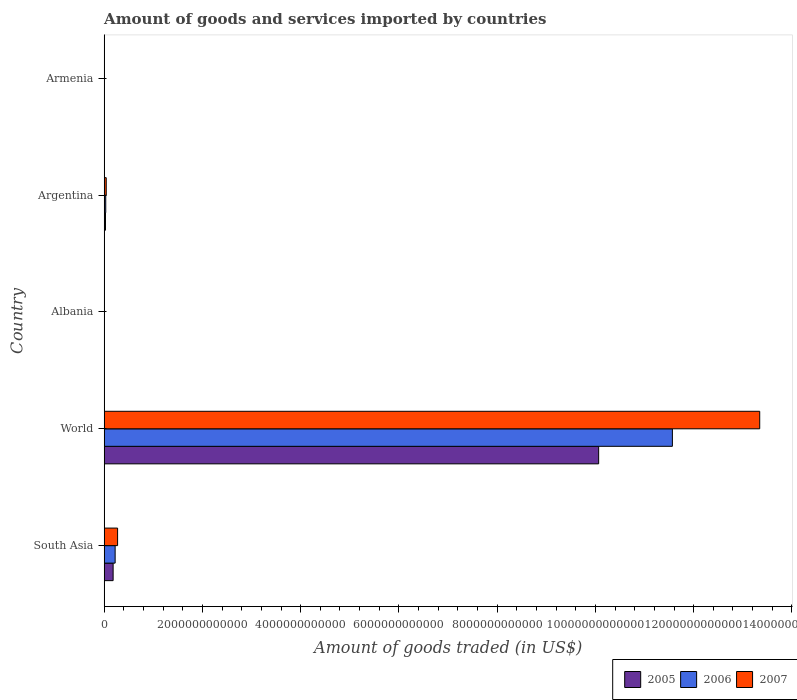Are the number of bars per tick equal to the number of legend labels?
Your answer should be very brief. Yes. What is the label of the 1st group of bars from the top?
Your answer should be compact. Armenia. In how many cases, is the number of bars for a given country not equal to the number of legend labels?
Give a very brief answer. 0. What is the total amount of goods and services imported in 2007 in Armenia?
Offer a terse response. 2.92e+09. Across all countries, what is the maximum total amount of goods and services imported in 2005?
Offer a very short reply. 1.01e+13. Across all countries, what is the minimum total amount of goods and services imported in 2006?
Provide a succinct answer. 2.00e+09. In which country was the total amount of goods and services imported in 2005 minimum?
Provide a succinct answer. Armenia. What is the total total amount of goods and services imported in 2006 in the graph?
Offer a very short reply. 1.18e+13. What is the difference between the total amount of goods and services imported in 2005 in Argentina and that in World?
Make the answer very short. -1.00e+13. What is the difference between the total amount of goods and services imported in 2006 in Albania and the total amount of goods and services imported in 2005 in World?
Provide a succinct answer. -1.01e+13. What is the average total amount of goods and services imported in 2006 per country?
Provide a short and direct response. 2.37e+12. What is the difference between the total amount of goods and services imported in 2005 and total amount of goods and services imported in 2006 in World?
Offer a very short reply. -1.50e+12. What is the ratio of the total amount of goods and services imported in 2006 in Albania to that in South Asia?
Ensure brevity in your answer.  0.01. Is the total amount of goods and services imported in 2005 in Armenia less than that in South Asia?
Provide a short and direct response. Yes. What is the difference between the highest and the second highest total amount of goods and services imported in 2007?
Offer a very short reply. 1.31e+13. What is the difference between the highest and the lowest total amount of goods and services imported in 2005?
Give a very brief answer. 1.01e+13. Is the sum of the total amount of goods and services imported in 2007 in Albania and Armenia greater than the maximum total amount of goods and services imported in 2006 across all countries?
Provide a succinct answer. No. Is it the case that in every country, the sum of the total amount of goods and services imported in 2005 and total amount of goods and services imported in 2006 is greater than the total amount of goods and services imported in 2007?
Make the answer very short. Yes. How many bars are there?
Keep it short and to the point. 15. Are all the bars in the graph horizontal?
Ensure brevity in your answer.  Yes. How many countries are there in the graph?
Your answer should be very brief. 5. What is the difference between two consecutive major ticks on the X-axis?
Keep it short and to the point. 2.00e+12. Are the values on the major ticks of X-axis written in scientific E-notation?
Provide a succinct answer. No. How many legend labels are there?
Keep it short and to the point. 3. How are the legend labels stacked?
Give a very brief answer. Horizontal. What is the title of the graph?
Ensure brevity in your answer.  Amount of goods and services imported by countries. What is the label or title of the X-axis?
Make the answer very short. Amount of goods traded (in US$). What is the Amount of goods traded (in US$) of 2005 in South Asia?
Provide a succinct answer. 1.83e+11. What is the Amount of goods traded (in US$) in 2006 in South Asia?
Your answer should be very brief. 2.24e+11. What is the Amount of goods traded (in US$) in 2007 in South Asia?
Provide a succinct answer. 2.74e+11. What is the Amount of goods traded (in US$) of 2005 in World?
Keep it short and to the point. 1.01e+13. What is the Amount of goods traded (in US$) of 2006 in World?
Make the answer very short. 1.16e+13. What is the Amount of goods traded (in US$) of 2007 in World?
Offer a terse response. 1.33e+13. What is the Amount of goods traded (in US$) of 2005 in Albania?
Keep it short and to the point. 2.12e+09. What is the Amount of goods traded (in US$) of 2006 in Albania?
Make the answer very short. 2.50e+09. What is the Amount of goods traded (in US$) in 2007 in Albania?
Offer a terse response. 3.42e+09. What is the Amount of goods traded (in US$) of 2005 in Argentina?
Ensure brevity in your answer.  2.73e+1. What is the Amount of goods traded (in US$) of 2006 in Argentina?
Your answer should be compact. 3.26e+1. What is the Amount of goods traded (in US$) in 2007 in Argentina?
Your answer should be very brief. 4.25e+1. What is the Amount of goods traded (in US$) of 2005 in Armenia?
Offer a terse response. 1.66e+09. What is the Amount of goods traded (in US$) of 2006 in Armenia?
Your answer should be compact. 2.00e+09. What is the Amount of goods traded (in US$) of 2007 in Armenia?
Offer a very short reply. 2.92e+09. Across all countries, what is the maximum Amount of goods traded (in US$) in 2005?
Your response must be concise. 1.01e+13. Across all countries, what is the maximum Amount of goods traded (in US$) in 2006?
Provide a succinct answer. 1.16e+13. Across all countries, what is the maximum Amount of goods traded (in US$) in 2007?
Offer a very short reply. 1.33e+13. Across all countries, what is the minimum Amount of goods traded (in US$) of 2005?
Your answer should be very brief. 1.66e+09. Across all countries, what is the minimum Amount of goods traded (in US$) of 2006?
Offer a terse response. 2.00e+09. Across all countries, what is the minimum Amount of goods traded (in US$) in 2007?
Your response must be concise. 2.92e+09. What is the total Amount of goods traded (in US$) of 2005 in the graph?
Make the answer very short. 1.03e+13. What is the total Amount of goods traded (in US$) of 2006 in the graph?
Offer a terse response. 1.18e+13. What is the total Amount of goods traded (in US$) of 2007 in the graph?
Your response must be concise. 1.37e+13. What is the difference between the Amount of goods traded (in US$) in 2005 in South Asia and that in World?
Your response must be concise. -9.88e+12. What is the difference between the Amount of goods traded (in US$) of 2006 in South Asia and that in World?
Your answer should be compact. -1.13e+13. What is the difference between the Amount of goods traded (in US$) of 2007 in South Asia and that in World?
Your response must be concise. -1.31e+13. What is the difference between the Amount of goods traded (in US$) in 2005 in South Asia and that in Albania?
Provide a succinct answer. 1.81e+11. What is the difference between the Amount of goods traded (in US$) in 2006 in South Asia and that in Albania?
Keep it short and to the point. 2.21e+11. What is the difference between the Amount of goods traded (in US$) of 2007 in South Asia and that in Albania?
Provide a short and direct response. 2.70e+11. What is the difference between the Amount of goods traded (in US$) in 2005 in South Asia and that in Argentina?
Give a very brief answer. 1.55e+11. What is the difference between the Amount of goods traded (in US$) of 2006 in South Asia and that in Argentina?
Your answer should be very brief. 1.91e+11. What is the difference between the Amount of goods traded (in US$) of 2007 in South Asia and that in Argentina?
Give a very brief answer. 2.31e+11. What is the difference between the Amount of goods traded (in US$) of 2005 in South Asia and that in Armenia?
Provide a short and direct response. 1.81e+11. What is the difference between the Amount of goods traded (in US$) of 2006 in South Asia and that in Armenia?
Provide a short and direct response. 2.22e+11. What is the difference between the Amount of goods traded (in US$) of 2007 in South Asia and that in Armenia?
Offer a very short reply. 2.71e+11. What is the difference between the Amount of goods traded (in US$) in 2005 in World and that in Albania?
Make the answer very short. 1.01e+13. What is the difference between the Amount of goods traded (in US$) of 2006 in World and that in Albania?
Offer a very short reply. 1.16e+13. What is the difference between the Amount of goods traded (in US$) of 2007 in World and that in Albania?
Provide a short and direct response. 1.33e+13. What is the difference between the Amount of goods traded (in US$) of 2005 in World and that in Argentina?
Keep it short and to the point. 1.00e+13. What is the difference between the Amount of goods traded (in US$) of 2006 in World and that in Argentina?
Give a very brief answer. 1.15e+13. What is the difference between the Amount of goods traded (in US$) in 2007 in World and that in Argentina?
Ensure brevity in your answer.  1.33e+13. What is the difference between the Amount of goods traded (in US$) of 2005 in World and that in Armenia?
Give a very brief answer. 1.01e+13. What is the difference between the Amount of goods traded (in US$) in 2006 in World and that in Armenia?
Your answer should be compact. 1.16e+13. What is the difference between the Amount of goods traded (in US$) of 2007 in World and that in Armenia?
Keep it short and to the point. 1.33e+13. What is the difference between the Amount of goods traded (in US$) of 2005 in Albania and that in Argentina?
Provide a succinct answer. -2.52e+1. What is the difference between the Amount of goods traded (in US$) of 2006 in Albania and that in Argentina?
Your response must be concise. -3.01e+1. What is the difference between the Amount of goods traded (in US$) in 2007 in Albania and that in Argentina?
Ensure brevity in your answer.  -3.91e+1. What is the difference between the Amount of goods traded (in US$) of 2005 in Albania and that in Armenia?
Offer a terse response. 4.54e+08. What is the difference between the Amount of goods traded (in US$) of 2006 in Albania and that in Armenia?
Your response must be concise. 5.00e+08. What is the difference between the Amount of goods traded (in US$) of 2007 in Albania and that in Armenia?
Offer a terse response. 4.99e+08. What is the difference between the Amount of goods traded (in US$) of 2005 in Argentina and that in Armenia?
Your response must be concise. 2.56e+1. What is the difference between the Amount of goods traded (in US$) in 2006 in Argentina and that in Armenia?
Ensure brevity in your answer.  3.06e+1. What is the difference between the Amount of goods traded (in US$) in 2007 in Argentina and that in Armenia?
Provide a succinct answer. 3.96e+1. What is the difference between the Amount of goods traded (in US$) in 2005 in South Asia and the Amount of goods traded (in US$) in 2006 in World?
Provide a succinct answer. -1.14e+13. What is the difference between the Amount of goods traded (in US$) in 2005 in South Asia and the Amount of goods traded (in US$) in 2007 in World?
Provide a short and direct response. -1.32e+13. What is the difference between the Amount of goods traded (in US$) in 2006 in South Asia and the Amount of goods traded (in US$) in 2007 in World?
Keep it short and to the point. -1.31e+13. What is the difference between the Amount of goods traded (in US$) of 2005 in South Asia and the Amount of goods traded (in US$) of 2006 in Albania?
Make the answer very short. 1.80e+11. What is the difference between the Amount of goods traded (in US$) in 2005 in South Asia and the Amount of goods traded (in US$) in 2007 in Albania?
Ensure brevity in your answer.  1.79e+11. What is the difference between the Amount of goods traded (in US$) of 2006 in South Asia and the Amount of goods traded (in US$) of 2007 in Albania?
Offer a terse response. 2.20e+11. What is the difference between the Amount of goods traded (in US$) of 2005 in South Asia and the Amount of goods traded (in US$) of 2006 in Argentina?
Offer a very short reply. 1.50e+11. What is the difference between the Amount of goods traded (in US$) in 2005 in South Asia and the Amount of goods traded (in US$) in 2007 in Argentina?
Your answer should be compact. 1.40e+11. What is the difference between the Amount of goods traded (in US$) of 2006 in South Asia and the Amount of goods traded (in US$) of 2007 in Argentina?
Give a very brief answer. 1.81e+11. What is the difference between the Amount of goods traded (in US$) in 2005 in South Asia and the Amount of goods traded (in US$) in 2006 in Armenia?
Your answer should be very brief. 1.81e+11. What is the difference between the Amount of goods traded (in US$) in 2005 in South Asia and the Amount of goods traded (in US$) in 2007 in Armenia?
Give a very brief answer. 1.80e+11. What is the difference between the Amount of goods traded (in US$) of 2006 in South Asia and the Amount of goods traded (in US$) of 2007 in Armenia?
Provide a short and direct response. 2.21e+11. What is the difference between the Amount of goods traded (in US$) in 2005 in World and the Amount of goods traded (in US$) in 2006 in Albania?
Offer a terse response. 1.01e+13. What is the difference between the Amount of goods traded (in US$) of 2005 in World and the Amount of goods traded (in US$) of 2007 in Albania?
Offer a very short reply. 1.01e+13. What is the difference between the Amount of goods traded (in US$) in 2006 in World and the Amount of goods traded (in US$) in 2007 in Albania?
Your response must be concise. 1.16e+13. What is the difference between the Amount of goods traded (in US$) in 2005 in World and the Amount of goods traded (in US$) in 2006 in Argentina?
Give a very brief answer. 1.00e+13. What is the difference between the Amount of goods traded (in US$) in 2005 in World and the Amount of goods traded (in US$) in 2007 in Argentina?
Give a very brief answer. 1.00e+13. What is the difference between the Amount of goods traded (in US$) of 2006 in World and the Amount of goods traded (in US$) of 2007 in Argentina?
Keep it short and to the point. 1.15e+13. What is the difference between the Amount of goods traded (in US$) of 2005 in World and the Amount of goods traded (in US$) of 2006 in Armenia?
Ensure brevity in your answer.  1.01e+13. What is the difference between the Amount of goods traded (in US$) in 2005 in World and the Amount of goods traded (in US$) in 2007 in Armenia?
Keep it short and to the point. 1.01e+13. What is the difference between the Amount of goods traded (in US$) in 2006 in World and the Amount of goods traded (in US$) in 2007 in Armenia?
Provide a short and direct response. 1.16e+13. What is the difference between the Amount of goods traded (in US$) in 2005 in Albania and the Amount of goods traded (in US$) in 2006 in Argentina?
Make the answer very short. -3.05e+1. What is the difference between the Amount of goods traded (in US$) of 2005 in Albania and the Amount of goods traded (in US$) of 2007 in Argentina?
Provide a succinct answer. -4.04e+1. What is the difference between the Amount of goods traded (in US$) of 2006 in Albania and the Amount of goods traded (in US$) of 2007 in Argentina?
Your answer should be compact. -4.00e+1. What is the difference between the Amount of goods traded (in US$) of 2005 in Albania and the Amount of goods traded (in US$) of 2006 in Armenia?
Your answer should be very brief. 1.18e+08. What is the difference between the Amount of goods traded (in US$) in 2005 in Albania and the Amount of goods traded (in US$) in 2007 in Armenia?
Give a very brief answer. -8.04e+08. What is the difference between the Amount of goods traded (in US$) in 2006 in Albania and the Amount of goods traded (in US$) in 2007 in Armenia?
Your answer should be compact. -4.21e+08. What is the difference between the Amount of goods traded (in US$) of 2005 in Argentina and the Amount of goods traded (in US$) of 2006 in Armenia?
Make the answer very short. 2.53e+1. What is the difference between the Amount of goods traded (in US$) of 2005 in Argentina and the Amount of goods traded (in US$) of 2007 in Armenia?
Provide a short and direct response. 2.44e+1. What is the difference between the Amount of goods traded (in US$) of 2006 in Argentina and the Amount of goods traded (in US$) of 2007 in Armenia?
Provide a short and direct response. 2.97e+1. What is the average Amount of goods traded (in US$) in 2005 per country?
Your answer should be very brief. 2.06e+12. What is the average Amount of goods traded (in US$) in 2006 per country?
Offer a terse response. 2.37e+12. What is the average Amount of goods traded (in US$) in 2007 per country?
Give a very brief answer. 2.73e+12. What is the difference between the Amount of goods traded (in US$) in 2005 and Amount of goods traded (in US$) in 2006 in South Asia?
Provide a short and direct response. -4.10e+1. What is the difference between the Amount of goods traded (in US$) in 2005 and Amount of goods traded (in US$) in 2007 in South Asia?
Your answer should be compact. -9.08e+1. What is the difference between the Amount of goods traded (in US$) of 2006 and Amount of goods traded (in US$) of 2007 in South Asia?
Ensure brevity in your answer.  -4.98e+1. What is the difference between the Amount of goods traded (in US$) of 2005 and Amount of goods traded (in US$) of 2006 in World?
Offer a very short reply. -1.50e+12. What is the difference between the Amount of goods traded (in US$) in 2005 and Amount of goods traded (in US$) in 2007 in World?
Your answer should be compact. -3.28e+12. What is the difference between the Amount of goods traded (in US$) in 2006 and Amount of goods traded (in US$) in 2007 in World?
Your answer should be compact. -1.78e+12. What is the difference between the Amount of goods traded (in US$) of 2005 and Amount of goods traded (in US$) of 2006 in Albania?
Provide a succinct answer. -3.82e+08. What is the difference between the Amount of goods traded (in US$) in 2005 and Amount of goods traded (in US$) in 2007 in Albania?
Make the answer very short. -1.30e+09. What is the difference between the Amount of goods traded (in US$) in 2006 and Amount of goods traded (in US$) in 2007 in Albania?
Give a very brief answer. -9.20e+08. What is the difference between the Amount of goods traded (in US$) of 2005 and Amount of goods traded (in US$) of 2006 in Argentina?
Provide a succinct answer. -5.29e+09. What is the difference between the Amount of goods traded (in US$) in 2005 and Amount of goods traded (in US$) in 2007 in Argentina?
Offer a very short reply. -1.52e+1. What is the difference between the Amount of goods traded (in US$) of 2006 and Amount of goods traded (in US$) of 2007 in Argentina?
Keep it short and to the point. -9.94e+09. What is the difference between the Amount of goods traded (in US$) of 2005 and Amount of goods traded (in US$) of 2006 in Armenia?
Provide a succinct answer. -3.37e+08. What is the difference between the Amount of goods traded (in US$) of 2005 and Amount of goods traded (in US$) of 2007 in Armenia?
Keep it short and to the point. -1.26e+09. What is the difference between the Amount of goods traded (in US$) of 2006 and Amount of goods traded (in US$) of 2007 in Armenia?
Give a very brief answer. -9.21e+08. What is the ratio of the Amount of goods traded (in US$) of 2005 in South Asia to that in World?
Give a very brief answer. 0.02. What is the ratio of the Amount of goods traded (in US$) in 2006 in South Asia to that in World?
Your response must be concise. 0.02. What is the ratio of the Amount of goods traded (in US$) in 2007 in South Asia to that in World?
Make the answer very short. 0.02. What is the ratio of the Amount of goods traded (in US$) in 2005 in South Asia to that in Albania?
Offer a very short reply. 86.28. What is the ratio of the Amount of goods traded (in US$) in 2006 in South Asia to that in Albania?
Offer a terse response. 89.49. What is the ratio of the Amount of goods traded (in US$) in 2007 in South Asia to that in Albania?
Ensure brevity in your answer.  79.98. What is the ratio of the Amount of goods traded (in US$) in 2005 in South Asia to that in Argentina?
Provide a short and direct response. 6.69. What is the ratio of the Amount of goods traded (in US$) in 2006 in South Asia to that in Argentina?
Make the answer very short. 6.86. What is the ratio of the Amount of goods traded (in US$) in 2007 in South Asia to that in Argentina?
Your answer should be compact. 6.43. What is the ratio of the Amount of goods traded (in US$) of 2005 in South Asia to that in Armenia?
Ensure brevity in your answer.  109.83. What is the ratio of the Amount of goods traded (in US$) of 2006 in South Asia to that in Armenia?
Provide a succinct answer. 111.86. What is the ratio of the Amount of goods traded (in US$) of 2007 in South Asia to that in Armenia?
Offer a terse response. 93.64. What is the ratio of the Amount of goods traded (in US$) of 2005 in World to that in Albania?
Keep it short and to the point. 4753.81. What is the ratio of the Amount of goods traded (in US$) of 2006 in World to that in Albania?
Make the answer very short. 4627.15. What is the ratio of the Amount of goods traded (in US$) of 2007 in World to that in Albania?
Offer a terse response. 3902.19. What is the ratio of the Amount of goods traded (in US$) of 2005 in World to that in Argentina?
Provide a succinct answer. 368.72. What is the ratio of the Amount of goods traded (in US$) in 2006 in World to that in Argentina?
Your answer should be compact. 354.94. What is the ratio of the Amount of goods traded (in US$) of 2007 in World to that in Argentina?
Offer a terse response. 313.8. What is the ratio of the Amount of goods traded (in US$) of 2005 in World to that in Armenia?
Offer a very short reply. 6051.57. What is the ratio of the Amount of goods traded (in US$) of 2006 in World to that in Armenia?
Your answer should be very brief. 5783.57. What is the ratio of the Amount of goods traded (in US$) of 2007 in World to that in Armenia?
Provide a succinct answer. 4568.25. What is the ratio of the Amount of goods traded (in US$) in 2005 in Albania to that in Argentina?
Provide a succinct answer. 0.08. What is the ratio of the Amount of goods traded (in US$) of 2006 in Albania to that in Argentina?
Offer a terse response. 0.08. What is the ratio of the Amount of goods traded (in US$) in 2007 in Albania to that in Argentina?
Provide a short and direct response. 0.08. What is the ratio of the Amount of goods traded (in US$) of 2005 in Albania to that in Armenia?
Offer a very short reply. 1.27. What is the ratio of the Amount of goods traded (in US$) of 2006 in Albania to that in Armenia?
Your answer should be compact. 1.25. What is the ratio of the Amount of goods traded (in US$) of 2007 in Albania to that in Armenia?
Offer a very short reply. 1.17. What is the ratio of the Amount of goods traded (in US$) in 2005 in Argentina to that in Armenia?
Offer a very short reply. 16.41. What is the ratio of the Amount of goods traded (in US$) of 2006 in Argentina to that in Armenia?
Provide a short and direct response. 16.29. What is the ratio of the Amount of goods traded (in US$) in 2007 in Argentina to that in Armenia?
Provide a short and direct response. 14.56. What is the difference between the highest and the second highest Amount of goods traded (in US$) of 2005?
Provide a short and direct response. 9.88e+12. What is the difference between the highest and the second highest Amount of goods traded (in US$) in 2006?
Provide a succinct answer. 1.13e+13. What is the difference between the highest and the second highest Amount of goods traded (in US$) in 2007?
Make the answer very short. 1.31e+13. What is the difference between the highest and the lowest Amount of goods traded (in US$) in 2005?
Ensure brevity in your answer.  1.01e+13. What is the difference between the highest and the lowest Amount of goods traded (in US$) of 2006?
Your answer should be compact. 1.16e+13. What is the difference between the highest and the lowest Amount of goods traded (in US$) in 2007?
Your answer should be very brief. 1.33e+13. 